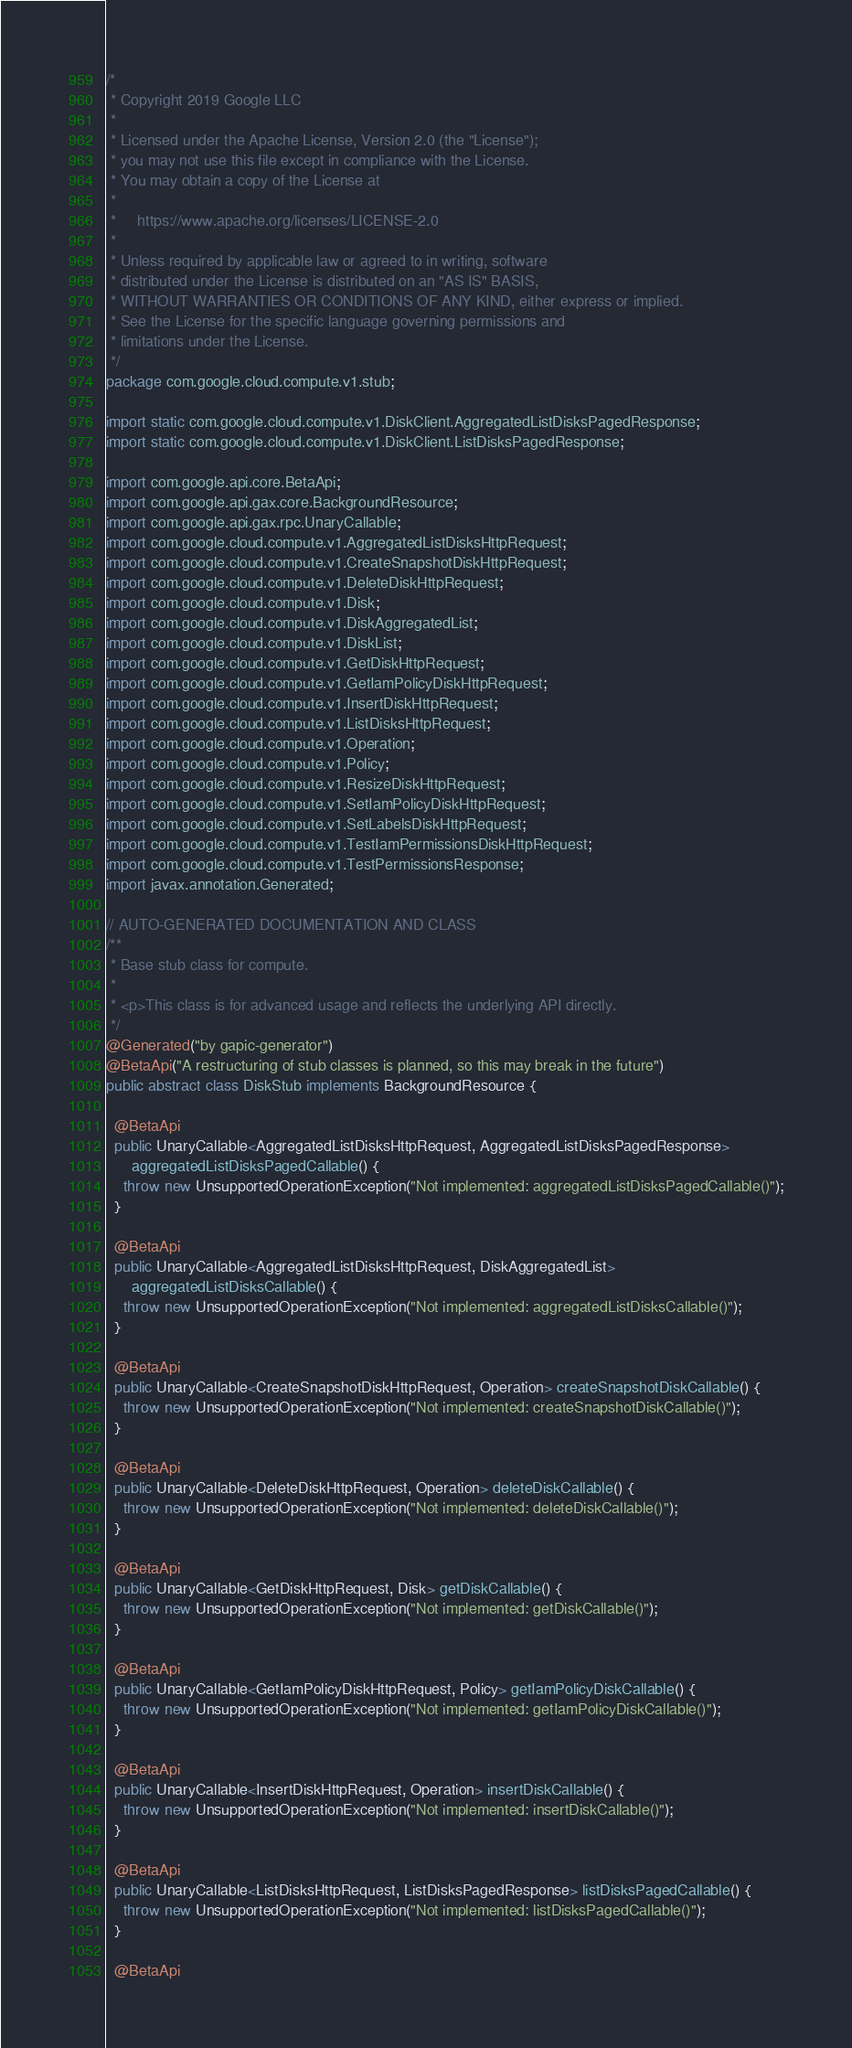<code> <loc_0><loc_0><loc_500><loc_500><_Java_>/*
 * Copyright 2019 Google LLC
 *
 * Licensed under the Apache License, Version 2.0 (the "License");
 * you may not use this file except in compliance with the License.
 * You may obtain a copy of the License at
 *
 *     https://www.apache.org/licenses/LICENSE-2.0
 *
 * Unless required by applicable law or agreed to in writing, software
 * distributed under the License is distributed on an "AS IS" BASIS,
 * WITHOUT WARRANTIES OR CONDITIONS OF ANY KIND, either express or implied.
 * See the License for the specific language governing permissions and
 * limitations under the License.
 */
package com.google.cloud.compute.v1.stub;

import static com.google.cloud.compute.v1.DiskClient.AggregatedListDisksPagedResponse;
import static com.google.cloud.compute.v1.DiskClient.ListDisksPagedResponse;

import com.google.api.core.BetaApi;
import com.google.api.gax.core.BackgroundResource;
import com.google.api.gax.rpc.UnaryCallable;
import com.google.cloud.compute.v1.AggregatedListDisksHttpRequest;
import com.google.cloud.compute.v1.CreateSnapshotDiskHttpRequest;
import com.google.cloud.compute.v1.DeleteDiskHttpRequest;
import com.google.cloud.compute.v1.Disk;
import com.google.cloud.compute.v1.DiskAggregatedList;
import com.google.cloud.compute.v1.DiskList;
import com.google.cloud.compute.v1.GetDiskHttpRequest;
import com.google.cloud.compute.v1.GetIamPolicyDiskHttpRequest;
import com.google.cloud.compute.v1.InsertDiskHttpRequest;
import com.google.cloud.compute.v1.ListDisksHttpRequest;
import com.google.cloud.compute.v1.Operation;
import com.google.cloud.compute.v1.Policy;
import com.google.cloud.compute.v1.ResizeDiskHttpRequest;
import com.google.cloud.compute.v1.SetIamPolicyDiskHttpRequest;
import com.google.cloud.compute.v1.SetLabelsDiskHttpRequest;
import com.google.cloud.compute.v1.TestIamPermissionsDiskHttpRequest;
import com.google.cloud.compute.v1.TestPermissionsResponse;
import javax.annotation.Generated;

// AUTO-GENERATED DOCUMENTATION AND CLASS
/**
 * Base stub class for compute.
 *
 * <p>This class is for advanced usage and reflects the underlying API directly.
 */
@Generated("by gapic-generator")
@BetaApi("A restructuring of stub classes is planned, so this may break in the future")
public abstract class DiskStub implements BackgroundResource {

  @BetaApi
  public UnaryCallable<AggregatedListDisksHttpRequest, AggregatedListDisksPagedResponse>
      aggregatedListDisksPagedCallable() {
    throw new UnsupportedOperationException("Not implemented: aggregatedListDisksPagedCallable()");
  }

  @BetaApi
  public UnaryCallable<AggregatedListDisksHttpRequest, DiskAggregatedList>
      aggregatedListDisksCallable() {
    throw new UnsupportedOperationException("Not implemented: aggregatedListDisksCallable()");
  }

  @BetaApi
  public UnaryCallable<CreateSnapshotDiskHttpRequest, Operation> createSnapshotDiskCallable() {
    throw new UnsupportedOperationException("Not implemented: createSnapshotDiskCallable()");
  }

  @BetaApi
  public UnaryCallable<DeleteDiskHttpRequest, Operation> deleteDiskCallable() {
    throw new UnsupportedOperationException("Not implemented: deleteDiskCallable()");
  }

  @BetaApi
  public UnaryCallable<GetDiskHttpRequest, Disk> getDiskCallable() {
    throw new UnsupportedOperationException("Not implemented: getDiskCallable()");
  }

  @BetaApi
  public UnaryCallable<GetIamPolicyDiskHttpRequest, Policy> getIamPolicyDiskCallable() {
    throw new UnsupportedOperationException("Not implemented: getIamPolicyDiskCallable()");
  }

  @BetaApi
  public UnaryCallable<InsertDiskHttpRequest, Operation> insertDiskCallable() {
    throw new UnsupportedOperationException("Not implemented: insertDiskCallable()");
  }

  @BetaApi
  public UnaryCallable<ListDisksHttpRequest, ListDisksPagedResponse> listDisksPagedCallable() {
    throw new UnsupportedOperationException("Not implemented: listDisksPagedCallable()");
  }

  @BetaApi</code> 